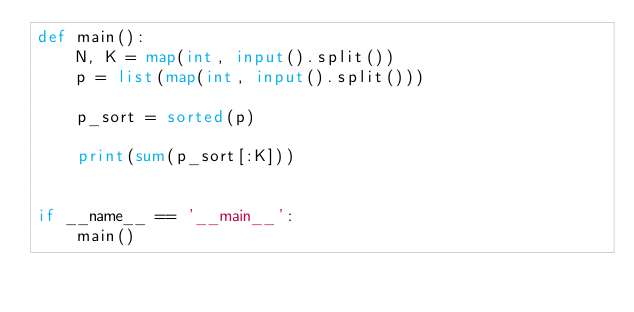<code> <loc_0><loc_0><loc_500><loc_500><_Python_>def main():
    N, K = map(int, input().split())
    p = list(map(int, input().split()))

    p_sort = sorted(p)

    print(sum(p_sort[:K]))


if __name__ == '__main__':
    main()</code> 